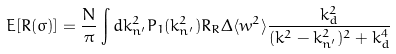<formula> <loc_0><loc_0><loc_500><loc_500>E [ R ( \sigma ) ] = \frac { N } { \pi } \int d k _ { n ^ { \prime } } ^ { 2 } P _ { 1 } ( k _ { n ^ { \prime } } ^ { 2 } ) R _ { R } \Delta \langle w ^ { 2 } \rangle \frac { k _ { d } ^ { 2 } } { ( k ^ { 2 } - k _ { n ^ { \prime } } ^ { 2 } ) ^ { 2 } + k _ { d } ^ { 4 } }</formula> 